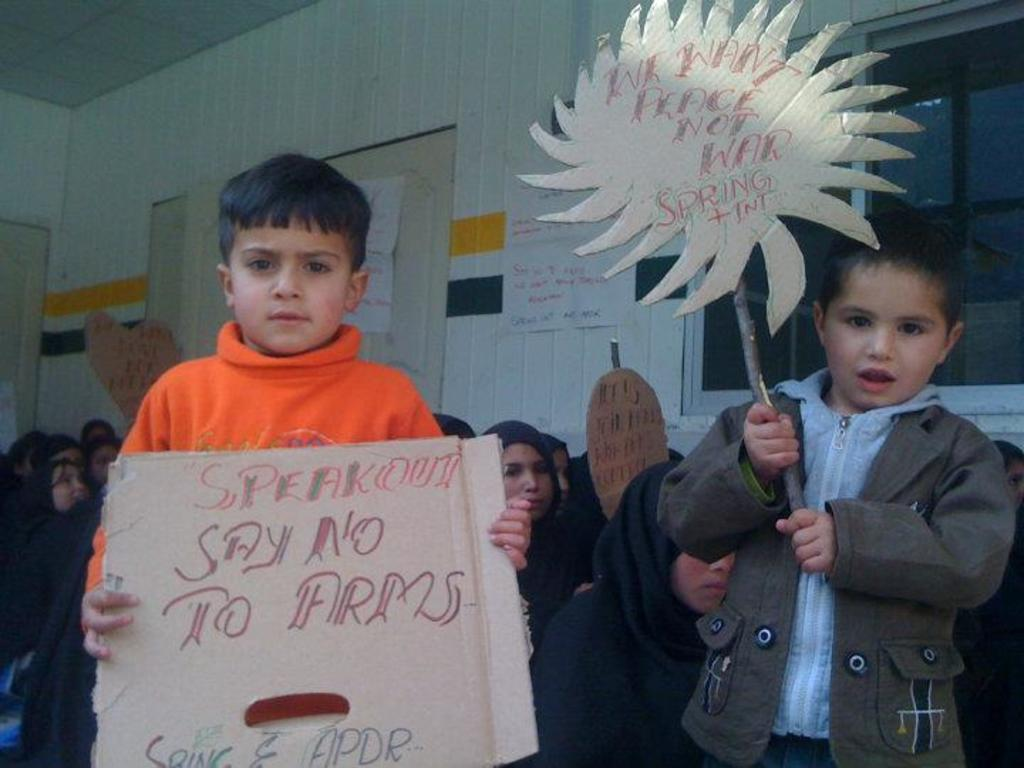How many boys are in the image? There are two boys in the image. What are the boys holding in the image? The boys are holding posters in the image. What can be seen in the background of the image? There is a group of people, a window, walls, and papers visible in the background. What type of bean is being discussed by the government in the image? There is no mention of beans or a government in the image. 